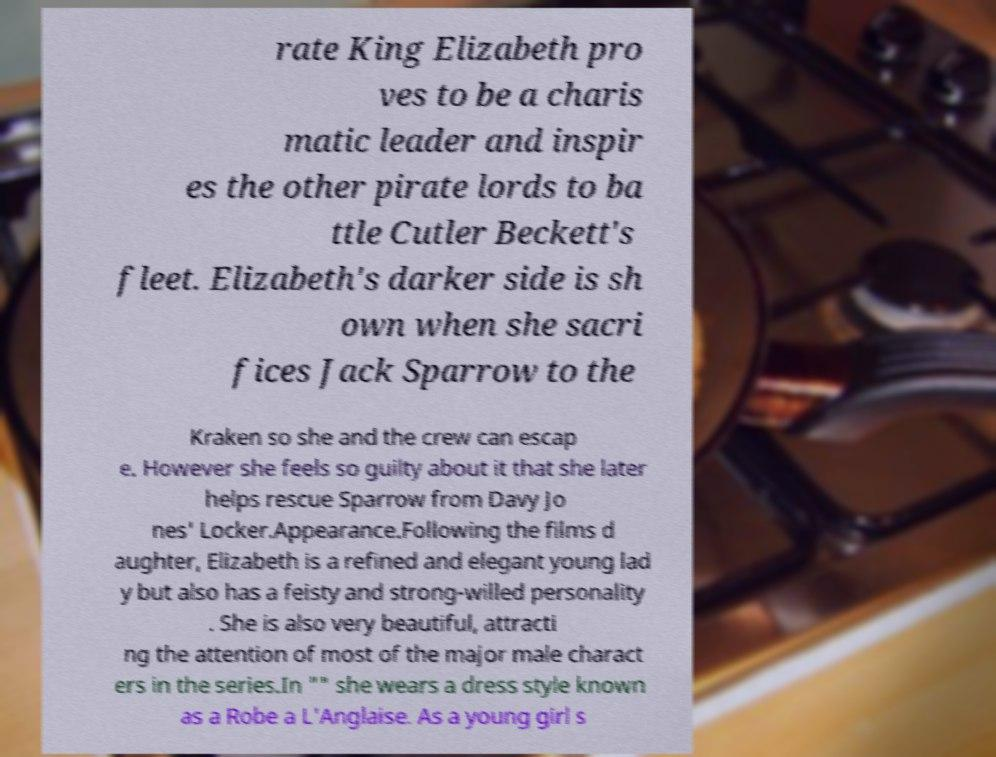There's text embedded in this image that I need extracted. Can you transcribe it verbatim? rate King Elizabeth pro ves to be a charis matic leader and inspir es the other pirate lords to ba ttle Cutler Beckett's fleet. Elizabeth's darker side is sh own when she sacri fices Jack Sparrow to the Kraken so she and the crew can escap e. However she feels so guilty about it that she later helps rescue Sparrow from Davy Jo nes' Locker.Appearance.Following the films d aughter, Elizabeth is a refined and elegant young lad y but also has a feisty and strong-willed personality . She is also very beautiful, attracti ng the attention of most of the major male charact ers in the series.In "" she wears a dress style known as a Robe a L'Anglaise. As a young girl s 